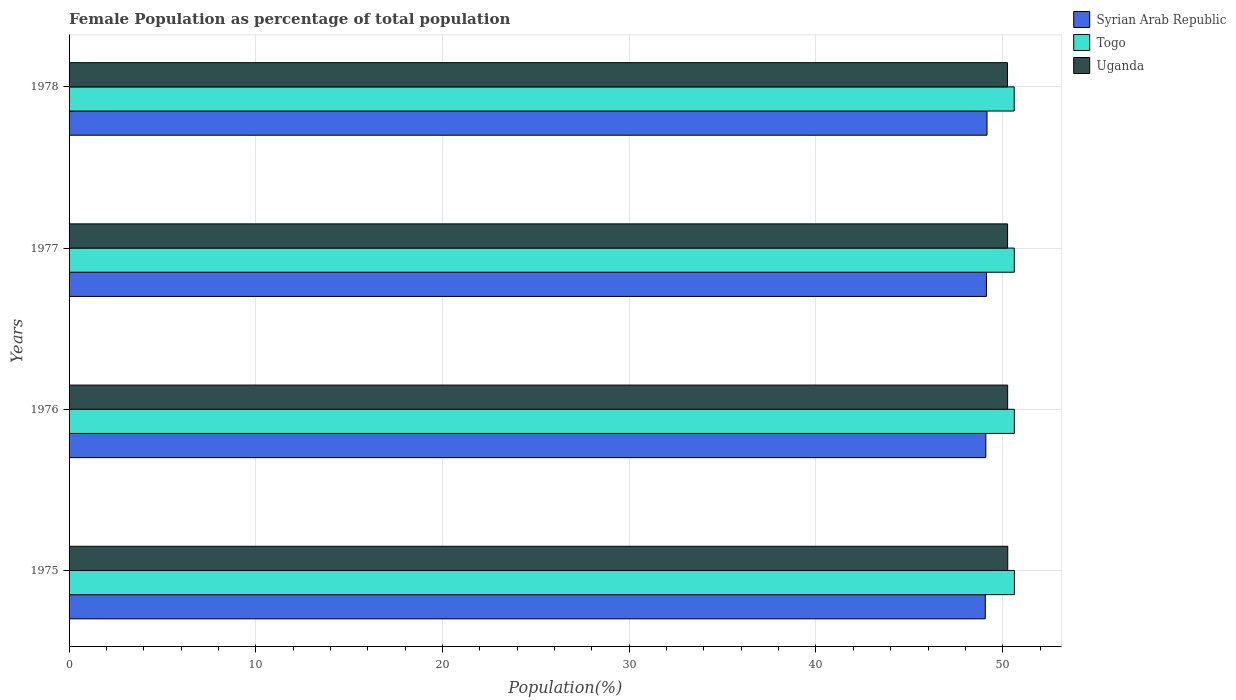How many groups of bars are there?
Your response must be concise. 4. Are the number of bars per tick equal to the number of legend labels?
Ensure brevity in your answer.  Yes. How many bars are there on the 4th tick from the bottom?
Your answer should be compact. 3. In how many cases, is the number of bars for a given year not equal to the number of legend labels?
Provide a succinct answer. 0. What is the female population in in Uganda in 1975?
Provide a short and direct response. 50.27. Across all years, what is the maximum female population in in Syrian Arab Republic?
Keep it short and to the point. 49.16. Across all years, what is the minimum female population in in Togo?
Your answer should be very brief. 50.62. In which year was the female population in in Uganda maximum?
Your answer should be very brief. 1975. In which year was the female population in in Syrian Arab Republic minimum?
Provide a succinct answer. 1975. What is the total female population in in Syrian Arab Republic in the graph?
Make the answer very short. 196.45. What is the difference between the female population in in Syrian Arab Republic in 1977 and that in 1978?
Provide a short and direct response. -0.03. What is the difference between the female population in in Togo in 1978 and the female population in in Uganda in 1977?
Your response must be concise. 0.35. What is the average female population in in Togo per year?
Ensure brevity in your answer.  50.62. In the year 1976, what is the difference between the female population in in Togo and female population in in Uganda?
Give a very brief answer. 0.36. What is the ratio of the female population in in Togo in 1975 to that in 1978?
Your response must be concise. 1. Is the female population in in Togo in 1975 less than that in 1978?
Your answer should be very brief. No. What is the difference between the highest and the second highest female population in in Togo?
Provide a short and direct response. 0. What is the difference between the highest and the lowest female population in in Syrian Arab Republic?
Provide a succinct answer. 0.09. What does the 3rd bar from the top in 1978 represents?
Offer a very short reply. Syrian Arab Republic. What does the 3rd bar from the bottom in 1976 represents?
Keep it short and to the point. Uganda. Are all the bars in the graph horizontal?
Offer a terse response. Yes. What is the difference between two consecutive major ticks on the X-axis?
Your answer should be very brief. 10. Where does the legend appear in the graph?
Keep it short and to the point. Top right. How many legend labels are there?
Ensure brevity in your answer.  3. How are the legend labels stacked?
Keep it short and to the point. Vertical. What is the title of the graph?
Your response must be concise. Female Population as percentage of total population. What is the label or title of the X-axis?
Give a very brief answer. Population(%). What is the Population(%) of Syrian Arab Republic in 1975?
Ensure brevity in your answer.  49.07. What is the Population(%) in Togo in 1975?
Your answer should be compact. 50.63. What is the Population(%) in Uganda in 1975?
Provide a short and direct response. 50.27. What is the Population(%) in Syrian Arab Republic in 1976?
Make the answer very short. 49.1. What is the Population(%) of Togo in 1976?
Your answer should be very brief. 50.62. What is the Population(%) in Uganda in 1976?
Provide a succinct answer. 50.27. What is the Population(%) in Syrian Arab Republic in 1977?
Ensure brevity in your answer.  49.13. What is the Population(%) of Togo in 1977?
Give a very brief answer. 50.62. What is the Population(%) of Uganda in 1977?
Offer a terse response. 50.26. What is the Population(%) of Syrian Arab Republic in 1978?
Make the answer very short. 49.16. What is the Population(%) of Togo in 1978?
Ensure brevity in your answer.  50.62. What is the Population(%) in Uganda in 1978?
Provide a short and direct response. 50.26. Across all years, what is the maximum Population(%) of Syrian Arab Republic?
Your response must be concise. 49.16. Across all years, what is the maximum Population(%) of Togo?
Provide a succinct answer. 50.63. Across all years, what is the maximum Population(%) of Uganda?
Offer a terse response. 50.27. Across all years, what is the minimum Population(%) of Syrian Arab Republic?
Offer a terse response. 49.07. Across all years, what is the minimum Population(%) in Togo?
Offer a very short reply. 50.62. Across all years, what is the minimum Population(%) of Uganda?
Make the answer very short. 50.26. What is the total Population(%) in Syrian Arab Republic in the graph?
Your answer should be very brief. 196.45. What is the total Population(%) of Togo in the graph?
Give a very brief answer. 202.49. What is the total Population(%) in Uganda in the graph?
Your answer should be compact. 201.06. What is the difference between the Population(%) in Syrian Arab Republic in 1975 and that in 1976?
Make the answer very short. -0.03. What is the difference between the Population(%) of Togo in 1975 and that in 1976?
Give a very brief answer. 0. What is the difference between the Population(%) in Uganda in 1975 and that in 1976?
Your answer should be compact. 0. What is the difference between the Population(%) in Syrian Arab Republic in 1975 and that in 1977?
Your response must be concise. -0.06. What is the difference between the Population(%) of Togo in 1975 and that in 1977?
Offer a terse response. 0.01. What is the difference between the Population(%) of Uganda in 1975 and that in 1977?
Provide a short and direct response. 0.01. What is the difference between the Population(%) of Syrian Arab Republic in 1975 and that in 1978?
Your response must be concise. -0.09. What is the difference between the Population(%) of Togo in 1975 and that in 1978?
Keep it short and to the point. 0.01. What is the difference between the Population(%) of Uganda in 1975 and that in 1978?
Offer a very short reply. 0.01. What is the difference between the Population(%) in Syrian Arab Republic in 1976 and that in 1977?
Ensure brevity in your answer.  -0.03. What is the difference between the Population(%) in Togo in 1976 and that in 1977?
Your answer should be compact. 0. What is the difference between the Population(%) of Uganda in 1976 and that in 1977?
Offer a terse response. 0. What is the difference between the Population(%) in Syrian Arab Republic in 1976 and that in 1978?
Offer a terse response. -0.06. What is the difference between the Population(%) in Togo in 1976 and that in 1978?
Keep it short and to the point. 0.01. What is the difference between the Population(%) in Uganda in 1976 and that in 1978?
Ensure brevity in your answer.  0.01. What is the difference between the Population(%) of Syrian Arab Republic in 1977 and that in 1978?
Keep it short and to the point. -0.03. What is the difference between the Population(%) in Togo in 1977 and that in 1978?
Offer a very short reply. 0. What is the difference between the Population(%) of Uganda in 1977 and that in 1978?
Make the answer very short. 0. What is the difference between the Population(%) in Syrian Arab Republic in 1975 and the Population(%) in Togo in 1976?
Your response must be concise. -1.56. What is the difference between the Population(%) of Syrian Arab Republic in 1975 and the Population(%) of Uganda in 1976?
Your answer should be very brief. -1.2. What is the difference between the Population(%) of Togo in 1975 and the Population(%) of Uganda in 1976?
Ensure brevity in your answer.  0.36. What is the difference between the Population(%) in Syrian Arab Republic in 1975 and the Population(%) in Togo in 1977?
Offer a terse response. -1.55. What is the difference between the Population(%) of Syrian Arab Republic in 1975 and the Population(%) of Uganda in 1977?
Keep it short and to the point. -1.19. What is the difference between the Population(%) of Togo in 1975 and the Population(%) of Uganda in 1977?
Your answer should be compact. 0.37. What is the difference between the Population(%) of Syrian Arab Republic in 1975 and the Population(%) of Togo in 1978?
Give a very brief answer. -1.55. What is the difference between the Population(%) in Syrian Arab Republic in 1975 and the Population(%) in Uganda in 1978?
Your answer should be very brief. -1.19. What is the difference between the Population(%) in Togo in 1975 and the Population(%) in Uganda in 1978?
Your answer should be compact. 0.37. What is the difference between the Population(%) in Syrian Arab Republic in 1976 and the Population(%) in Togo in 1977?
Your response must be concise. -1.52. What is the difference between the Population(%) of Syrian Arab Republic in 1976 and the Population(%) of Uganda in 1977?
Give a very brief answer. -1.17. What is the difference between the Population(%) of Togo in 1976 and the Population(%) of Uganda in 1977?
Ensure brevity in your answer.  0.36. What is the difference between the Population(%) in Syrian Arab Republic in 1976 and the Population(%) in Togo in 1978?
Your answer should be compact. -1.52. What is the difference between the Population(%) in Syrian Arab Republic in 1976 and the Population(%) in Uganda in 1978?
Provide a succinct answer. -1.16. What is the difference between the Population(%) in Togo in 1976 and the Population(%) in Uganda in 1978?
Offer a very short reply. 0.37. What is the difference between the Population(%) in Syrian Arab Republic in 1977 and the Population(%) in Togo in 1978?
Provide a succinct answer. -1.49. What is the difference between the Population(%) of Syrian Arab Republic in 1977 and the Population(%) of Uganda in 1978?
Offer a terse response. -1.13. What is the difference between the Population(%) of Togo in 1977 and the Population(%) of Uganda in 1978?
Offer a terse response. 0.36. What is the average Population(%) in Syrian Arab Republic per year?
Provide a short and direct response. 49.11. What is the average Population(%) in Togo per year?
Your response must be concise. 50.62. What is the average Population(%) in Uganda per year?
Offer a terse response. 50.26. In the year 1975, what is the difference between the Population(%) in Syrian Arab Republic and Population(%) in Togo?
Your answer should be compact. -1.56. In the year 1975, what is the difference between the Population(%) of Syrian Arab Republic and Population(%) of Uganda?
Provide a succinct answer. -1.2. In the year 1975, what is the difference between the Population(%) in Togo and Population(%) in Uganda?
Offer a very short reply. 0.36. In the year 1976, what is the difference between the Population(%) of Syrian Arab Republic and Population(%) of Togo?
Make the answer very short. -1.53. In the year 1976, what is the difference between the Population(%) of Syrian Arab Republic and Population(%) of Uganda?
Offer a very short reply. -1.17. In the year 1976, what is the difference between the Population(%) of Togo and Population(%) of Uganda?
Keep it short and to the point. 0.36. In the year 1977, what is the difference between the Population(%) of Syrian Arab Republic and Population(%) of Togo?
Your response must be concise. -1.49. In the year 1977, what is the difference between the Population(%) of Syrian Arab Republic and Population(%) of Uganda?
Ensure brevity in your answer.  -1.13. In the year 1977, what is the difference between the Population(%) in Togo and Population(%) in Uganda?
Offer a terse response. 0.36. In the year 1978, what is the difference between the Population(%) in Syrian Arab Republic and Population(%) in Togo?
Offer a very short reply. -1.46. In the year 1978, what is the difference between the Population(%) in Syrian Arab Republic and Population(%) in Uganda?
Offer a very short reply. -1.1. In the year 1978, what is the difference between the Population(%) of Togo and Population(%) of Uganda?
Your answer should be very brief. 0.36. What is the ratio of the Population(%) in Togo in 1975 to that in 1976?
Keep it short and to the point. 1. What is the ratio of the Population(%) in Togo in 1975 to that in 1977?
Make the answer very short. 1. What is the ratio of the Population(%) in Syrian Arab Republic in 1976 to that in 1977?
Your answer should be compact. 1. What is the ratio of the Population(%) of Togo in 1976 to that in 1977?
Ensure brevity in your answer.  1. What is the ratio of the Population(%) in Uganda in 1976 to that in 1977?
Your answer should be compact. 1. What is the ratio of the Population(%) in Syrian Arab Republic in 1976 to that in 1978?
Provide a succinct answer. 1. What is the ratio of the Population(%) of Togo in 1976 to that in 1978?
Provide a short and direct response. 1. What is the ratio of the Population(%) of Uganda in 1976 to that in 1978?
Your answer should be compact. 1. What is the ratio of the Population(%) of Togo in 1977 to that in 1978?
Keep it short and to the point. 1. What is the ratio of the Population(%) in Uganda in 1977 to that in 1978?
Offer a very short reply. 1. What is the difference between the highest and the second highest Population(%) in Syrian Arab Republic?
Provide a short and direct response. 0.03. What is the difference between the highest and the second highest Population(%) of Togo?
Keep it short and to the point. 0. What is the difference between the highest and the second highest Population(%) in Uganda?
Ensure brevity in your answer.  0. What is the difference between the highest and the lowest Population(%) in Syrian Arab Republic?
Provide a succinct answer. 0.09. What is the difference between the highest and the lowest Population(%) of Togo?
Provide a succinct answer. 0.01. What is the difference between the highest and the lowest Population(%) in Uganda?
Provide a short and direct response. 0.01. 